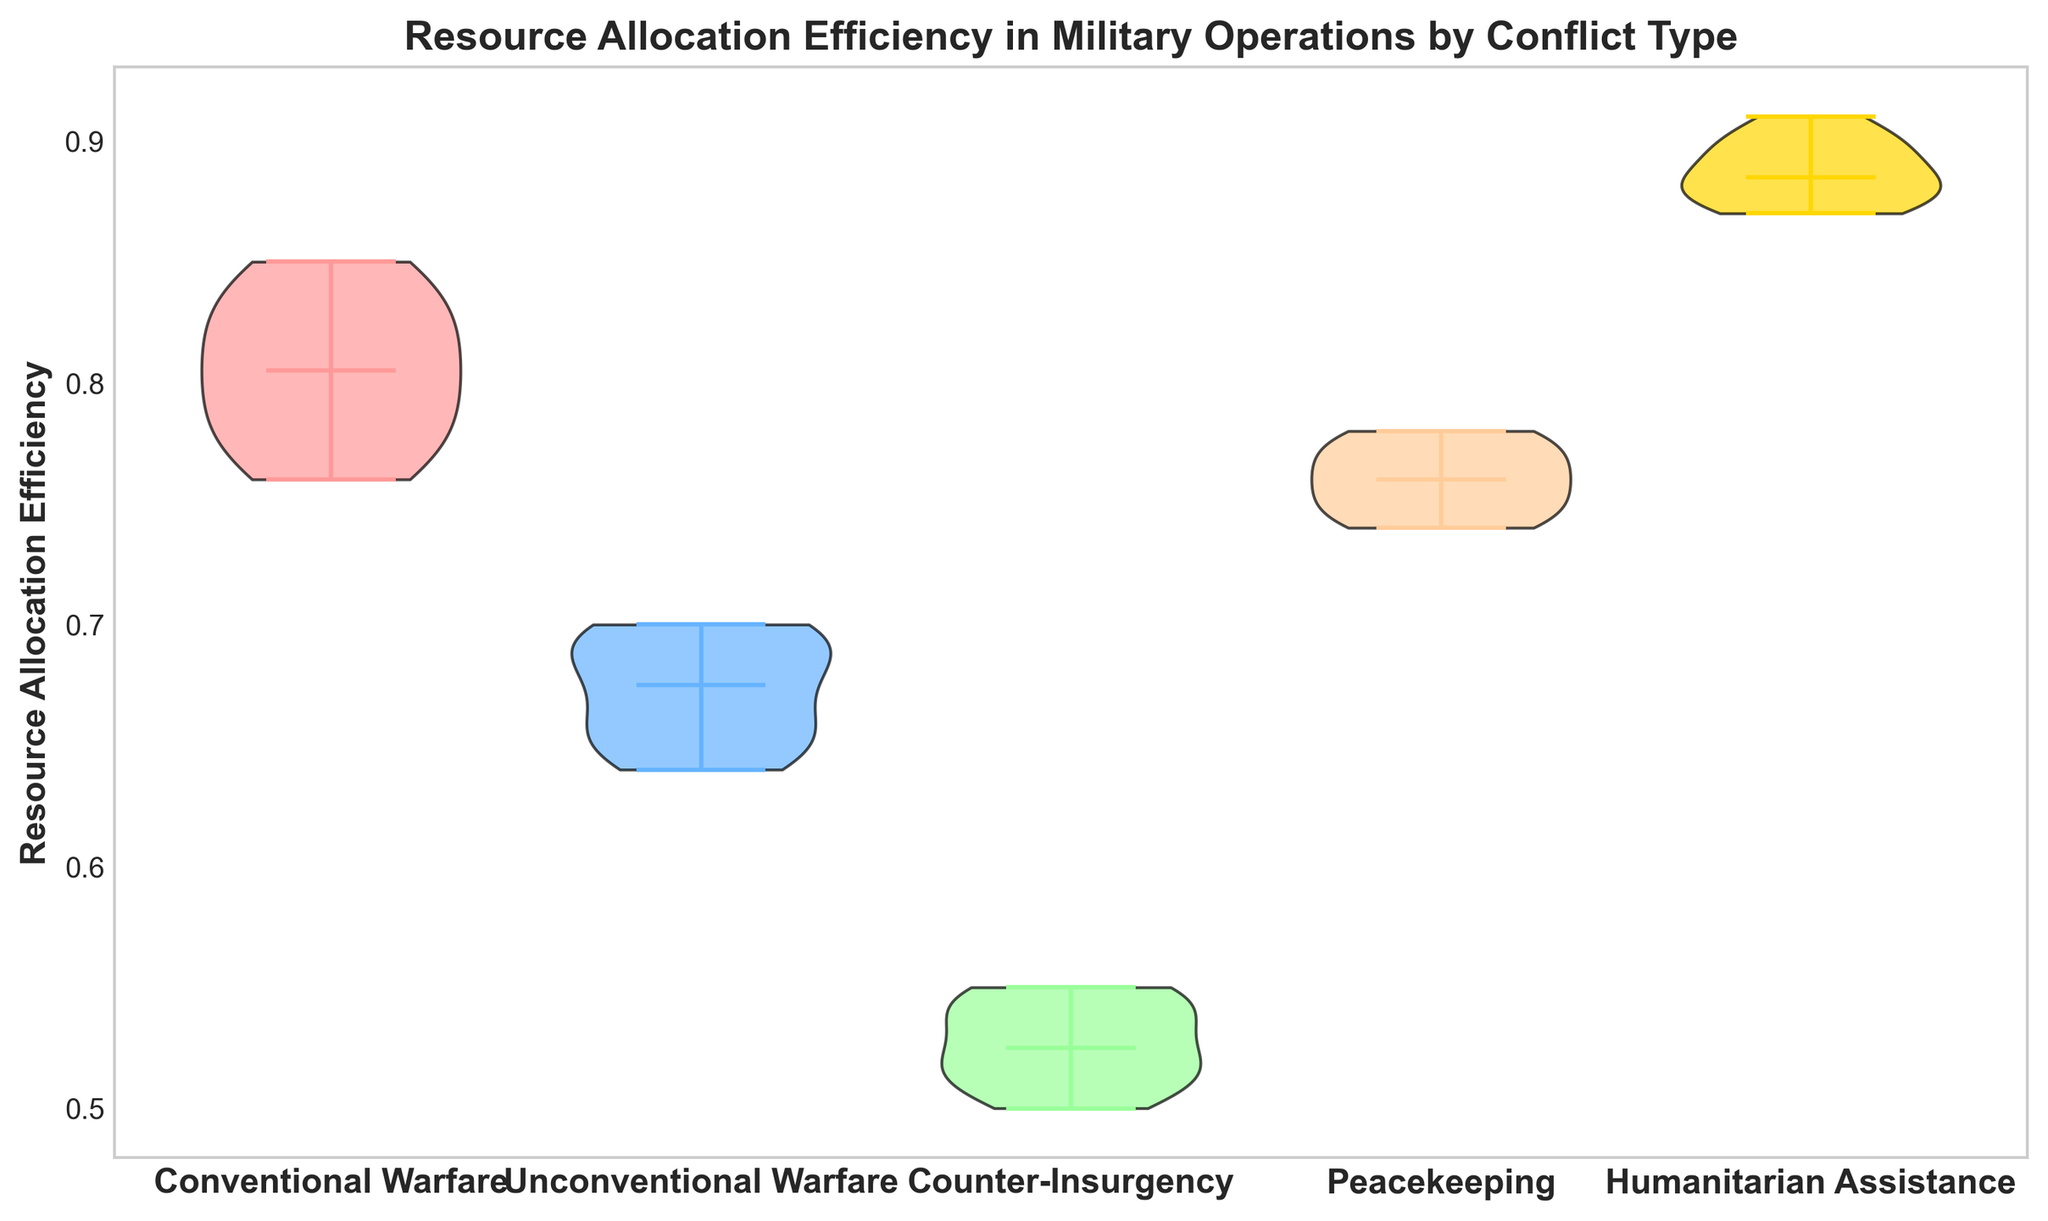What is the median Resource Allocation Efficiency for Conventional Warfare? To find the median, we need to identify the middle value when the values are arranged in order. For Conventional Warfare, the values sorted are: 0.76, 0.77, 0.78, 0.79, 0.80, 0.81, 0.82, 0.83, 0.84, 0.85. The median is the average of the 5th and 6th values: (0.80 + 0.81) / 2 = 0.805
Answer: 0.805 Which conflict type shows the highest median Resource Allocation Efficiency? By looking at the median indicators (typically horizontal bars) in the figure, we can compare the medians of each conflict type. Humanitarian Assistance shows the highest median value among all groups.
Answer: Humanitarian Assistance What is the difference in median Resource Allocation Efficiency between Unconventional Warfare and Counter-Insurgency? To calculate the difference, identify the medians visually: Unconventional Warfare has a median around 0.66, and Counter-Insurgency has a median around 0.52. The difference is 0.66 - 0.52 = 0.14
Answer: 0.14 How does the median Resource Allocation Efficiency for Peacekeeping compare to Conventional Warfare? Visually check the median positions for both Peacekeeping and Conventional Warfare. Peacekeeping has a median close to 0.75, while Conventional Warfare's median is around 0.805. Therefore, the median for Peacekeeping is lower than that for Conventional Warfare.
Answer: Peacekeeping < Conventional Warfare Which conflict type has the most variability in Resource Allocation Efficiency? Variability can be assessed by the width of the violin plots. Counter-Insurgency shows a more spread-out and broader distribution, indicating higher variability compared to other conflict types.
Answer: Counter-Insurgency 